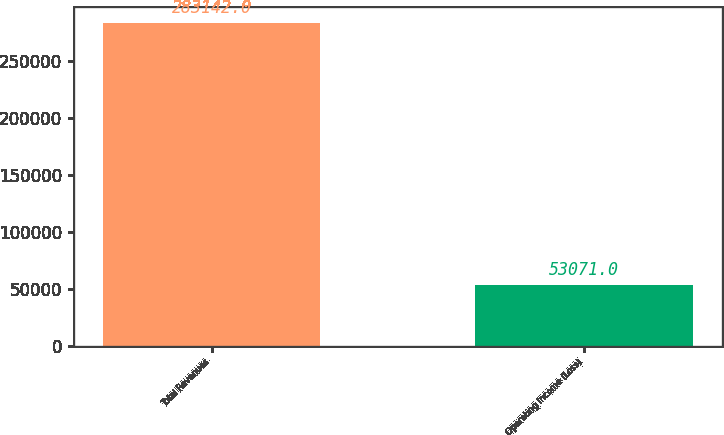<chart> <loc_0><loc_0><loc_500><loc_500><bar_chart><fcel>Total Revenues<fcel>Operating Income (Loss)<nl><fcel>283142<fcel>53071<nl></chart> 